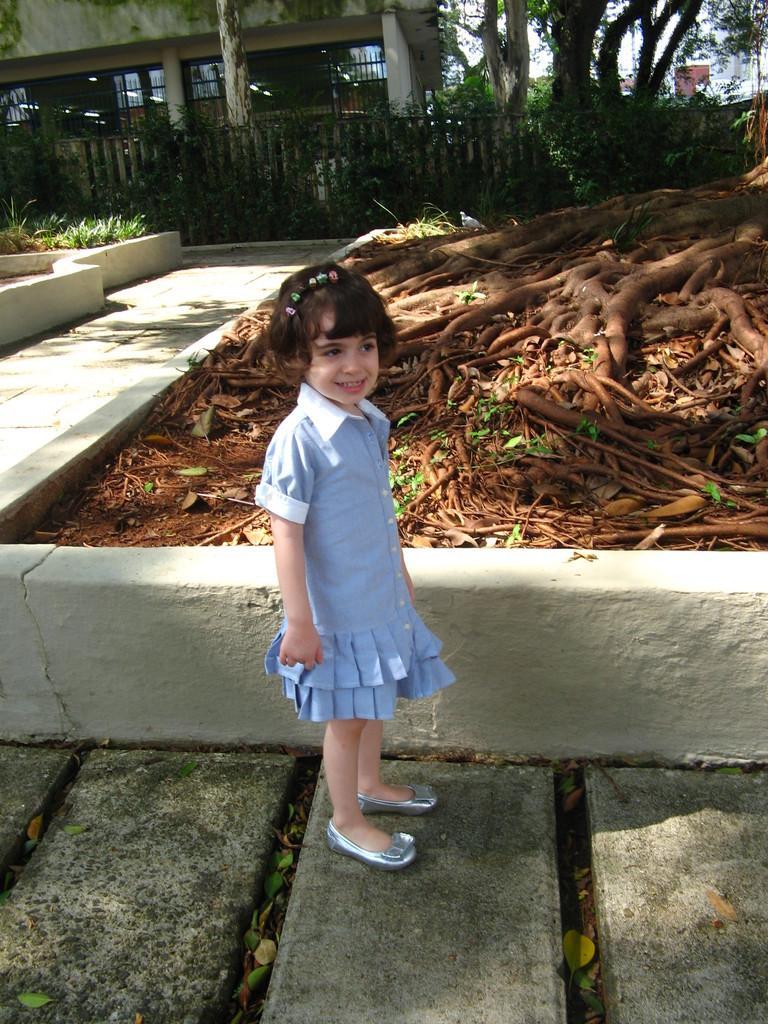In one or two sentences, can you explain what this image depicts? In this picture there is a girl standing and we can see tree roots and grass. In the background of the image we can see fence, trees, wall and sky. 